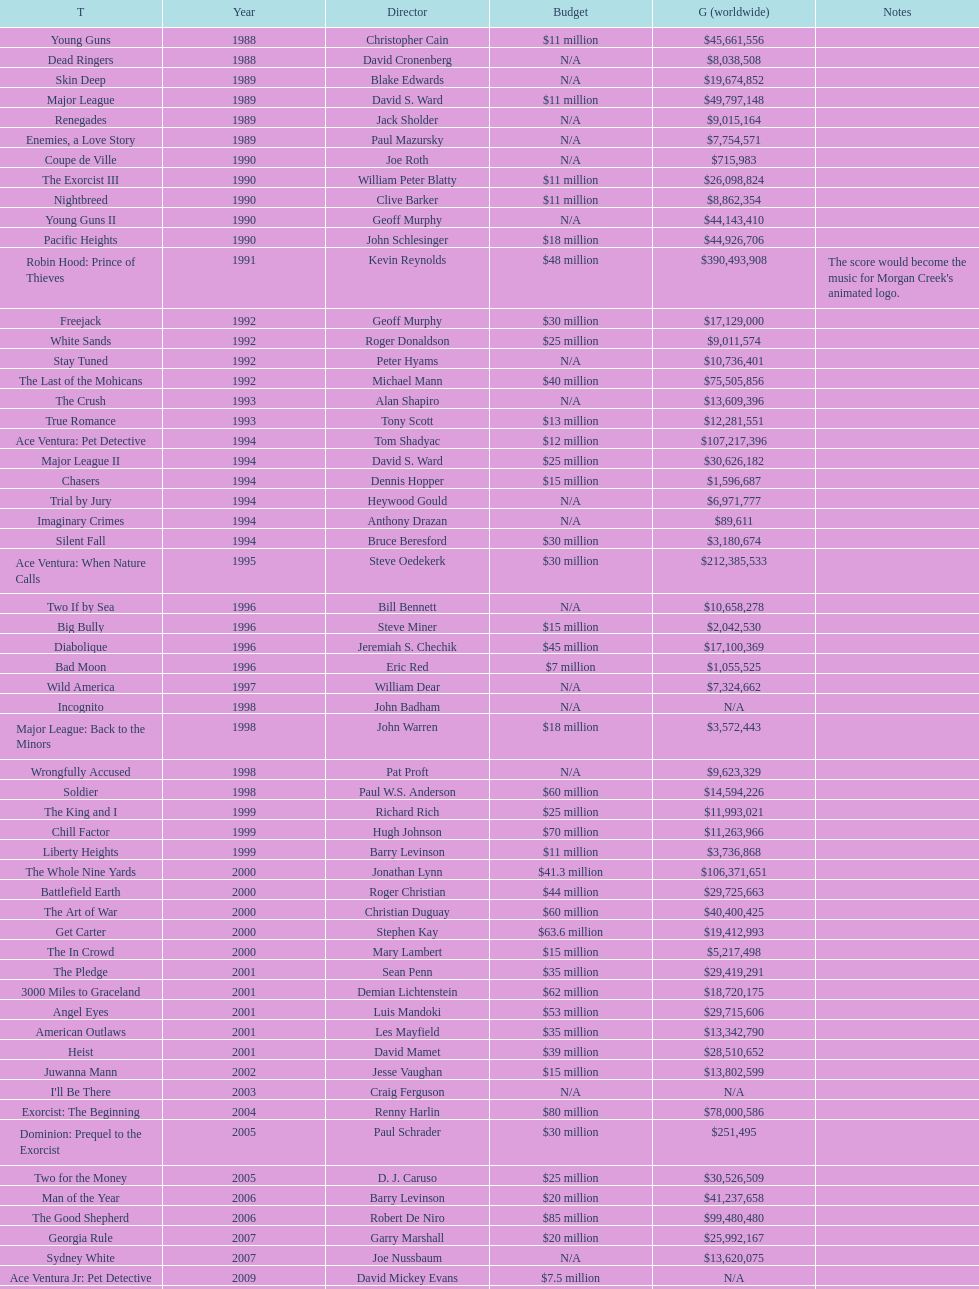Was the young guns budget higher or lower than freejack's budget? Less. Can you parse all the data within this table? {'header': ['T', 'Year', 'Director', 'Budget', 'G (worldwide)', 'Notes'], 'rows': [['Young Guns', '1988', 'Christopher Cain', '$11 million', '$45,661,556', ''], ['Dead Ringers', '1988', 'David Cronenberg', 'N/A', '$8,038,508', ''], ['Skin Deep', '1989', 'Blake Edwards', 'N/A', '$19,674,852', ''], ['Major League', '1989', 'David S. Ward', '$11 million', '$49,797,148', ''], ['Renegades', '1989', 'Jack Sholder', 'N/A', '$9,015,164', ''], ['Enemies, a Love Story', '1989', 'Paul Mazursky', 'N/A', '$7,754,571', ''], ['Coupe de Ville', '1990', 'Joe Roth', 'N/A', '$715,983', ''], ['The Exorcist III', '1990', 'William Peter Blatty', '$11 million', '$26,098,824', ''], ['Nightbreed', '1990', 'Clive Barker', '$11 million', '$8,862,354', ''], ['Young Guns II', '1990', 'Geoff Murphy', 'N/A', '$44,143,410', ''], ['Pacific Heights', '1990', 'John Schlesinger', '$18 million', '$44,926,706', ''], ['Robin Hood: Prince of Thieves', '1991', 'Kevin Reynolds', '$48 million', '$390,493,908', "The score would become the music for Morgan Creek's animated logo."], ['Freejack', '1992', 'Geoff Murphy', '$30 million', '$17,129,000', ''], ['White Sands', '1992', 'Roger Donaldson', '$25 million', '$9,011,574', ''], ['Stay Tuned', '1992', 'Peter Hyams', 'N/A', '$10,736,401', ''], ['The Last of the Mohicans', '1992', 'Michael Mann', '$40 million', '$75,505,856', ''], ['The Crush', '1993', 'Alan Shapiro', 'N/A', '$13,609,396', ''], ['True Romance', '1993', 'Tony Scott', '$13 million', '$12,281,551', ''], ['Ace Ventura: Pet Detective', '1994', 'Tom Shadyac', '$12 million', '$107,217,396', ''], ['Major League II', '1994', 'David S. Ward', '$25 million', '$30,626,182', ''], ['Chasers', '1994', 'Dennis Hopper', '$15 million', '$1,596,687', ''], ['Trial by Jury', '1994', 'Heywood Gould', 'N/A', '$6,971,777', ''], ['Imaginary Crimes', '1994', 'Anthony Drazan', 'N/A', '$89,611', ''], ['Silent Fall', '1994', 'Bruce Beresford', '$30 million', '$3,180,674', ''], ['Ace Ventura: When Nature Calls', '1995', 'Steve Oedekerk', '$30 million', '$212,385,533', ''], ['Two If by Sea', '1996', 'Bill Bennett', 'N/A', '$10,658,278', ''], ['Big Bully', '1996', 'Steve Miner', '$15 million', '$2,042,530', ''], ['Diabolique', '1996', 'Jeremiah S. Chechik', '$45 million', '$17,100,369', ''], ['Bad Moon', '1996', 'Eric Red', '$7 million', '$1,055,525', ''], ['Wild America', '1997', 'William Dear', 'N/A', '$7,324,662', ''], ['Incognito', '1998', 'John Badham', 'N/A', 'N/A', ''], ['Major League: Back to the Minors', '1998', 'John Warren', '$18 million', '$3,572,443', ''], ['Wrongfully Accused', '1998', 'Pat Proft', 'N/A', '$9,623,329', ''], ['Soldier', '1998', 'Paul W.S. Anderson', '$60 million', '$14,594,226', ''], ['The King and I', '1999', 'Richard Rich', '$25 million', '$11,993,021', ''], ['Chill Factor', '1999', 'Hugh Johnson', '$70 million', '$11,263,966', ''], ['Liberty Heights', '1999', 'Barry Levinson', '$11 million', '$3,736,868', ''], ['The Whole Nine Yards', '2000', 'Jonathan Lynn', '$41.3 million', '$106,371,651', ''], ['Battlefield Earth', '2000', 'Roger Christian', '$44 million', '$29,725,663', ''], ['The Art of War', '2000', 'Christian Duguay', '$60 million', '$40,400,425', ''], ['Get Carter', '2000', 'Stephen Kay', '$63.6 million', '$19,412,993', ''], ['The In Crowd', '2000', 'Mary Lambert', '$15 million', '$5,217,498', ''], ['The Pledge', '2001', 'Sean Penn', '$35 million', '$29,419,291', ''], ['3000 Miles to Graceland', '2001', 'Demian Lichtenstein', '$62 million', '$18,720,175', ''], ['Angel Eyes', '2001', 'Luis Mandoki', '$53 million', '$29,715,606', ''], ['American Outlaws', '2001', 'Les Mayfield', '$35 million', '$13,342,790', ''], ['Heist', '2001', 'David Mamet', '$39 million', '$28,510,652', ''], ['Juwanna Mann', '2002', 'Jesse Vaughan', '$15 million', '$13,802,599', ''], ["I'll Be There", '2003', 'Craig Ferguson', 'N/A', 'N/A', ''], ['Exorcist: The Beginning', '2004', 'Renny Harlin', '$80 million', '$78,000,586', ''], ['Dominion: Prequel to the Exorcist', '2005', 'Paul Schrader', '$30 million', '$251,495', ''], ['Two for the Money', '2005', 'D. J. Caruso', '$25 million', '$30,526,509', ''], ['Man of the Year', '2006', 'Barry Levinson', '$20 million', '$41,237,658', ''], ['The Good Shepherd', '2006', 'Robert De Niro', '$85 million', '$99,480,480', ''], ['Georgia Rule', '2007', 'Garry Marshall', '$20 million', '$25,992,167', ''], ['Sydney White', '2007', 'Joe Nussbaum', 'N/A', '$13,620,075', ''], ['Ace Ventura Jr: Pet Detective', '2009', 'David Mickey Evans', '$7.5 million', 'N/A', ''], ['Dream House', '2011', 'Jim Sheridan', '$50 million', '$38,502,340', ''], ['The Thing', '2011', 'Matthijs van Heijningen Jr.', '$38 million', '$27,428,670', ''], ['Tupac', '2014', 'Antoine Fuqua', '$45 million', '', '']]} 